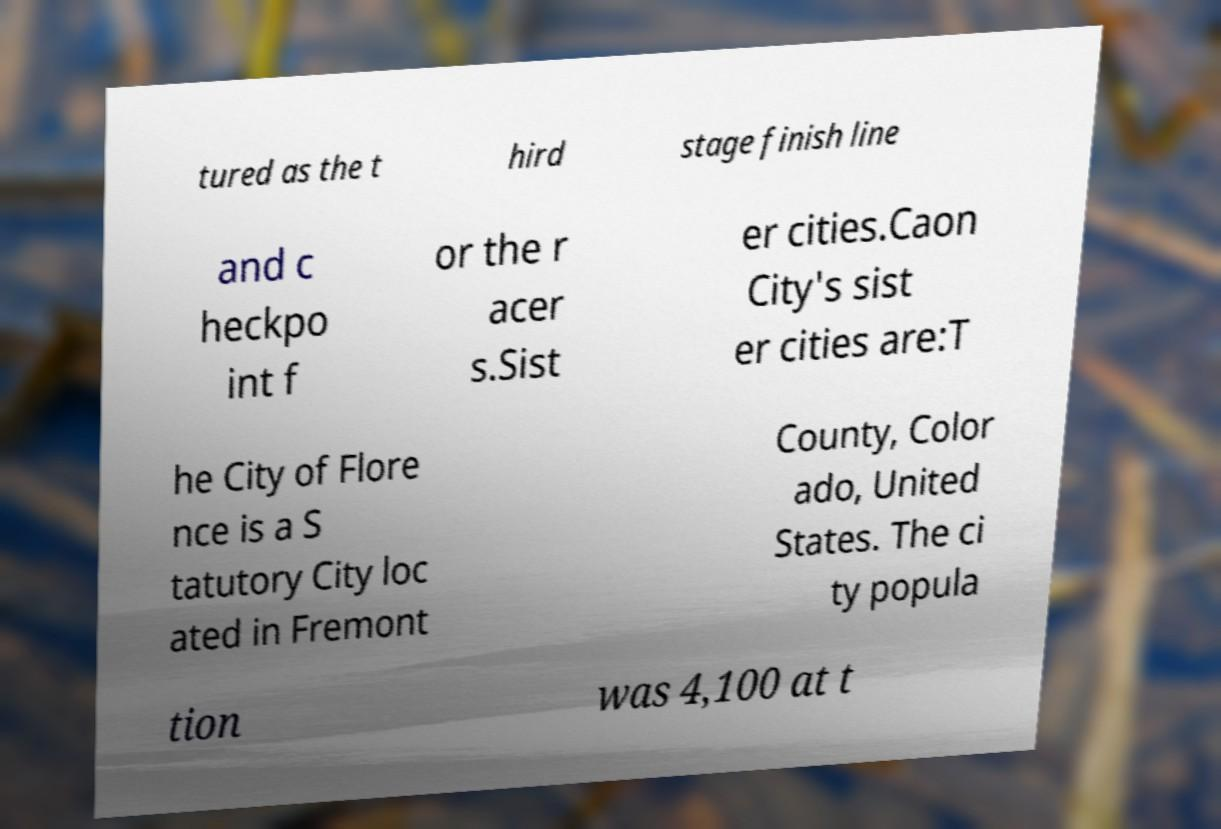What messages or text are displayed in this image? I need them in a readable, typed format. tured as the t hird stage finish line and c heckpo int f or the r acer s.Sist er cities.Caon City's sist er cities are:T he City of Flore nce is a S tatutory City loc ated in Fremont County, Color ado, United States. The ci ty popula tion was 4,100 at t 